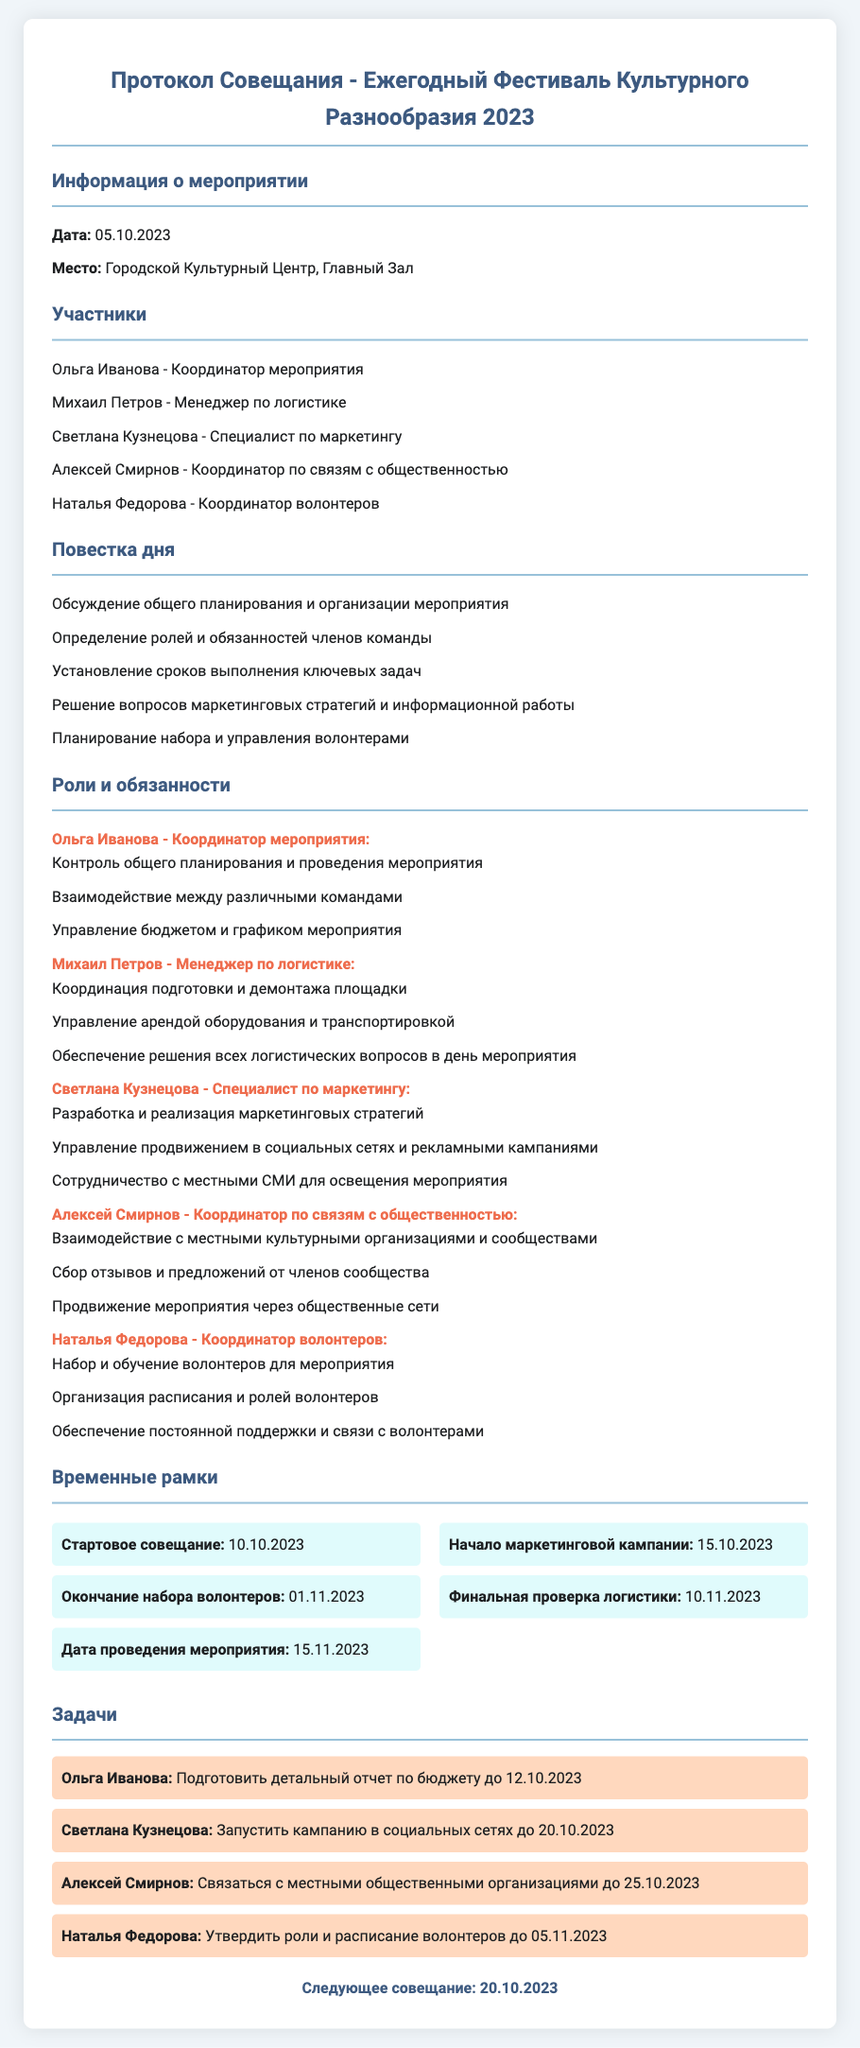что обсуждалось на совещании? Обсуждались вопросы планирования и организации мероприятия, распределения ролей, сроков задач, маркетинговых стратегий и набора волонтеров.
Answer: общий план мероприятий кто является координатором мероприятия? В документе указано, что Ольга Иванова является координатором мероприятия.
Answer: Ольга Иванова какая дата проведения мероприятия? В указателе времени написано, что дата проведения мероприятия 15.11.2023.
Answer: 15.11.2023 кто отвечает за маркетинг? Светлана Кузнецова является специалистом по маркетингу и отвечает за маркетинговые стратегии.
Answer: Светлана Кузнецова как долго будет продолжаться маркетинговая кампания? Начало кампании запланировано на 15.10.2023, а срок её не указан, что подразумевает, что она будет продолжаться до мероприятия 15.11.2023.
Answer: с 15.10.2023 до 15.11.2023 какое задание должен выполнить Алексей Смирнов? Алексей Смирнов должен связаться с местными общественными организациями до 25.10.2023.
Answer: Связаться с местными общественными организациями что нужно сделать до 12.10.2023? Ольга Иванова должна подготовить детальный отчет по бюджету до указанной даты.
Answer: Подготовить детальный отчет по бюджету когда пройдет следующее совещание? В документе указано, что следующее совещание состоится 20.10.2023.
Answer: 20.10.2023 какова роль Натальи Федоровой? Наталья Федорова отвечает за координацию волонтеров на мероприятии.
Answer: Координатор волонтеров 